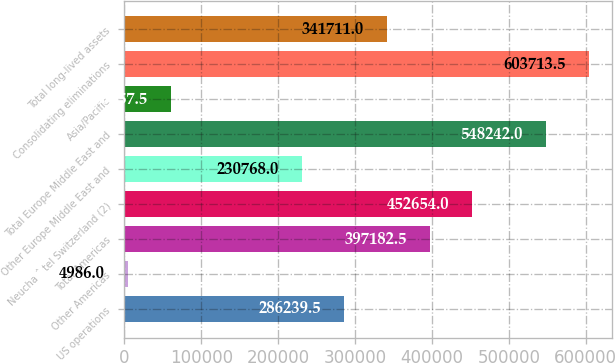<chart> <loc_0><loc_0><loc_500><loc_500><bar_chart><fcel>US operations<fcel>Other Americas<fcel>Total Americas<fcel>Neucha ˆ tel Switzerland (2)<fcel>Other Europe Middle East and<fcel>Total Europe Middle East and<fcel>Asia/Pacific<fcel>Consolidating eliminations<fcel>Total long-lived assets<nl><fcel>286240<fcel>4986<fcel>397182<fcel>452654<fcel>230768<fcel>548242<fcel>60457.5<fcel>603714<fcel>341711<nl></chart> 